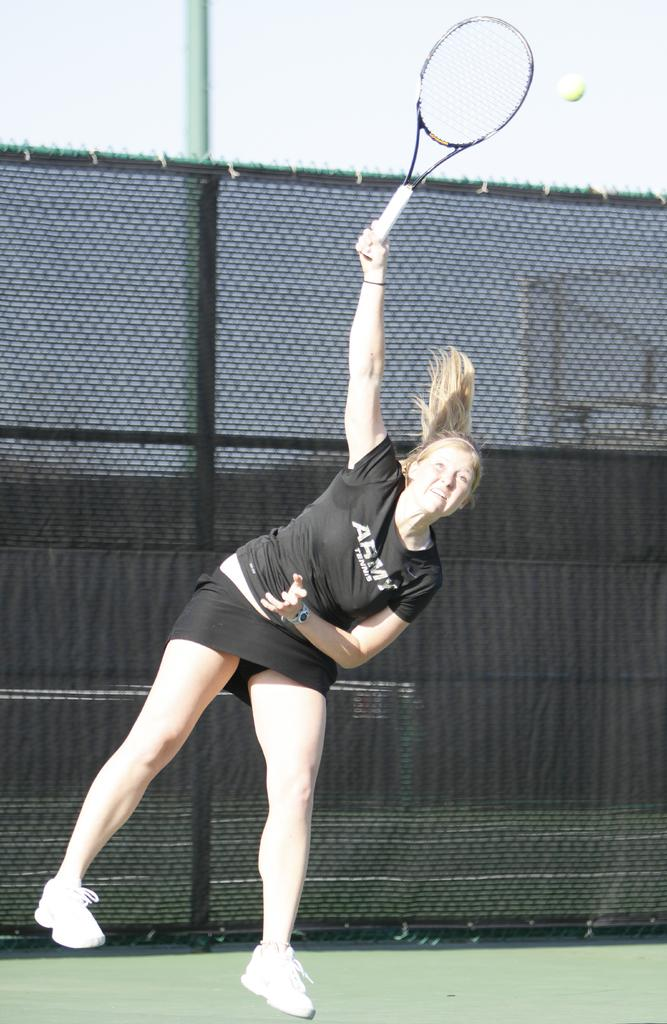Who is the main subject in the image? There is a woman in the image. What activity is the woman engaged in? The woman is playing badminton. What is used to separate the two sides in the game? There is a badminton net in the image. What type of surface is visible in the image? The ground is visible in the image. What type of lumber is being used to construct the badminton net in the image? There is no information about the construction materials of the badminton net in the image. How much salt is visible on the ground in the image? There is no salt visible on the ground in the image. 